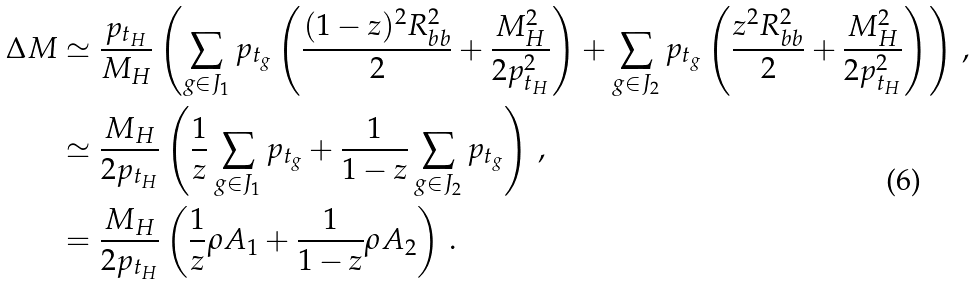Convert formula to latex. <formula><loc_0><loc_0><loc_500><loc_500>\Delta M & \simeq \frac { p _ { t _ { H } } } { M _ { H } } \left ( \sum _ { g \in J _ { 1 } } p _ { t _ { g } } \left ( \frac { ( 1 - z ) ^ { 2 } R _ { b b } ^ { 2 } } { 2 } + \frac { M _ { H } ^ { 2 } } { 2 p _ { t _ { H } } ^ { 2 } } \right ) + \sum _ { g \in J _ { 2 } } p _ { t _ { g } } \left ( \frac { z ^ { 2 } R _ { b b } ^ { 2 } } { 2 } + \frac { M _ { H } ^ { 2 } } { 2 p _ { t _ { H } } ^ { 2 } } \right ) \right ) \, , \\ & \simeq \frac { M _ { H } } { 2 p _ { t _ { H } } } \left ( \frac { 1 } { z } \sum _ { g \in J _ { 1 } } p _ { t _ { g } } + \frac { 1 } { 1 - z } \sum _ { g \in J _ { 2 } } p _ { t _ { g } } \right ) \, , \\ & = \frac { M _ { H } } { 2 p _ { t _ { H } } } \left ( \frac { 1 } { z } \rho A _ { 1 } + \frac { 1 } { 1 - z } \rho A _ { 2 } \right ) \, .</formula> 